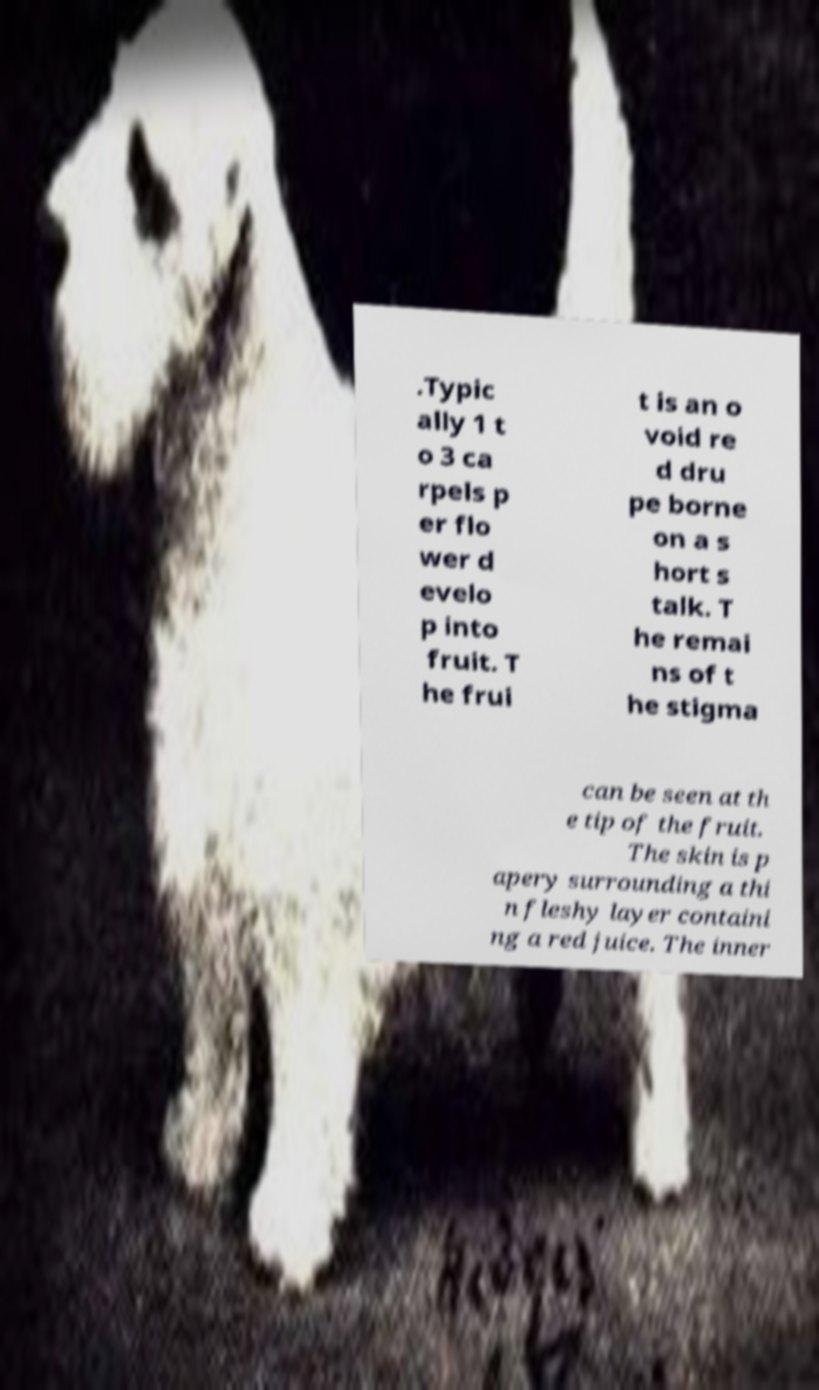What messages or text are displayed in this image? I need them in a readable, typed format. .Typic ally 1 t o 3 ca rpels p er flo wer d evelo p into fruit. T he frui t is an o void re d dru pe borne on a s hort s talk. T he remai ns of t he stigma can be seen at th e tip of the fruit. The skin is p apery surrounding a thi n fleshy layer containi ng a red juice. The inner 